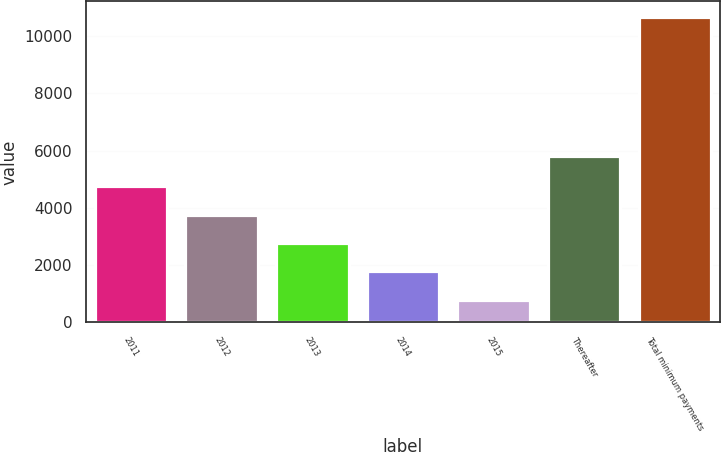<chart> <loc_0><loc_0><loc_500><loc_500><bar_chart><fcel>2011<fcel>2012<fcel>2013<fcel>2014<fcel>2015<fcel>Thereafter<fcel>Total minimum payments<nl><fcel>4747.24<fcel>3759.78<fcel>2772.32<fcel>1784.86<fcel>797.4<fcel>5823.6<fcel>10672<nl></chart> 